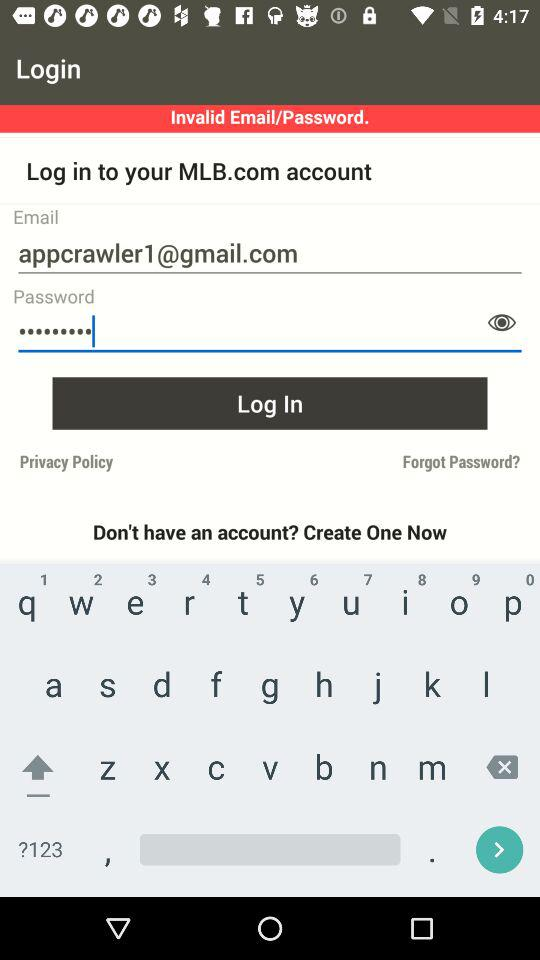Where can I find and purchase seats? You can find and purchase seats directly from the app. 